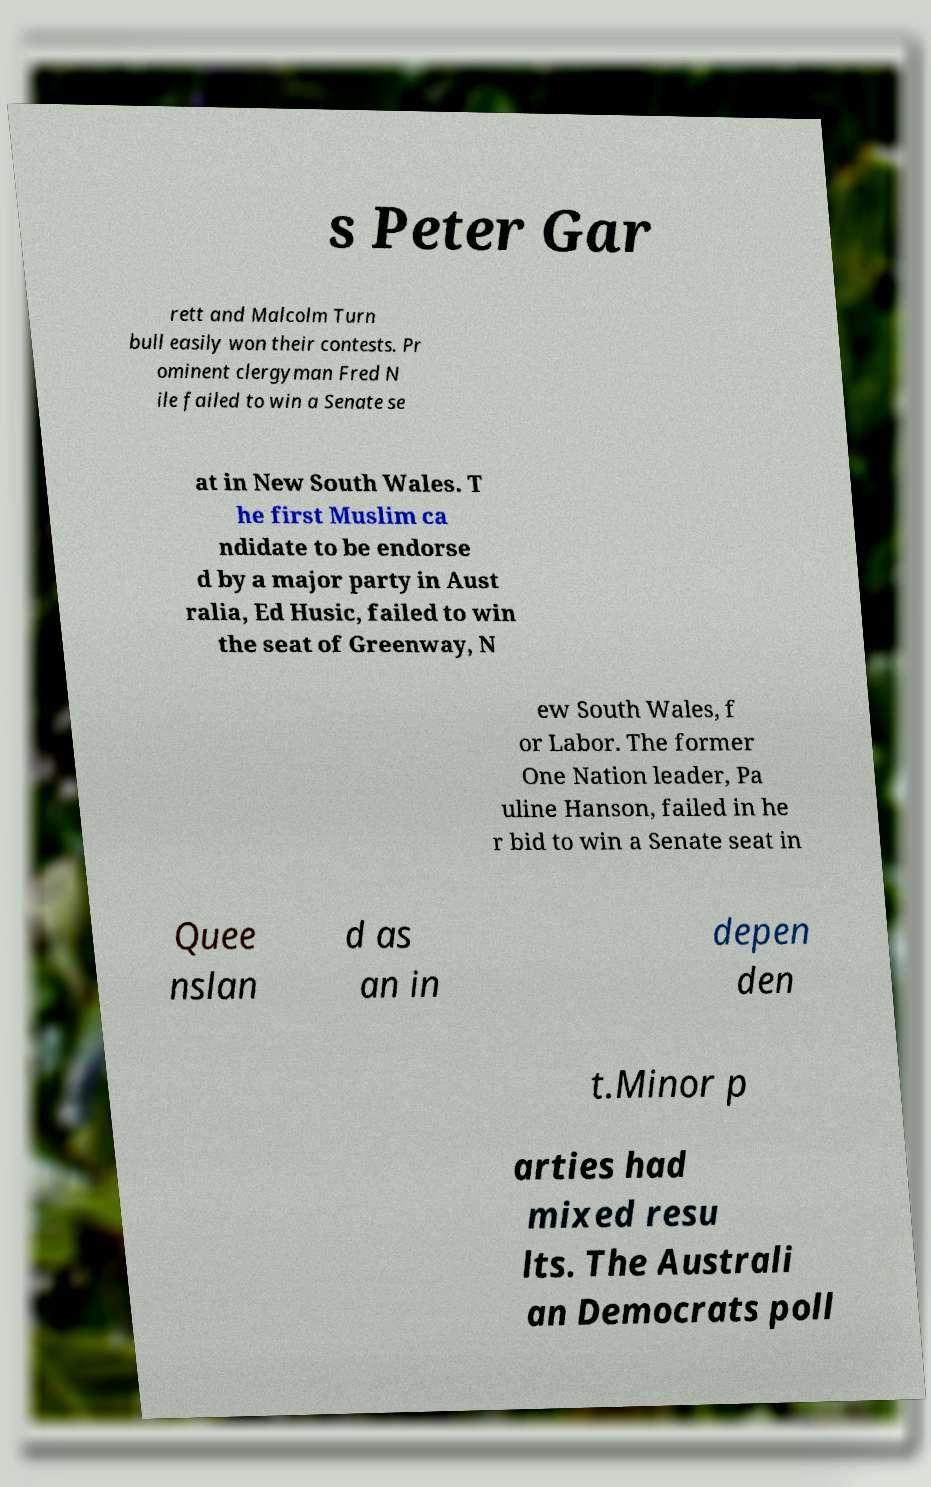Please read and relay the text visible in this image. What does it say? s Peter Gar rett and Malcolm Turn bull easily won their contests. Pr ominent clergyman Fred N ile failed to win a Senate se at in New South Wales. T he first Muslim ca ndidate to be endorse d by a major party in Aust ralia, Ed Husic, failed to win the seat of Greenway, N ew South Wales, f or Labor. The former One Nation leader, Pa uline Hanson, failed in he r bid to win a Senate seat in Quee nslan d as an in depen den t.Minor p arties had mixed resu lts. The Australi an Democrats poll 